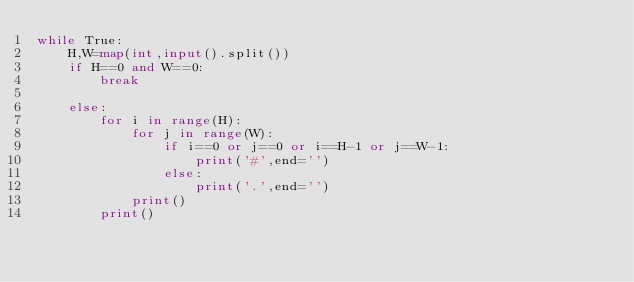Convert code to text. <code><loc_0><loc_0><loc_500><loc_500><_Python_>while True:
    H,W=map(int,input().split())
    if H==0 and W==0:
        break
    
    else:
        for i in range(H):
            for j in range(W):
                if i==0 or j==0 or i==H-1 or j==W-1:
                    print('#',end='')
                else:
                    print('.',end='')
            print()
        print()

</code> 